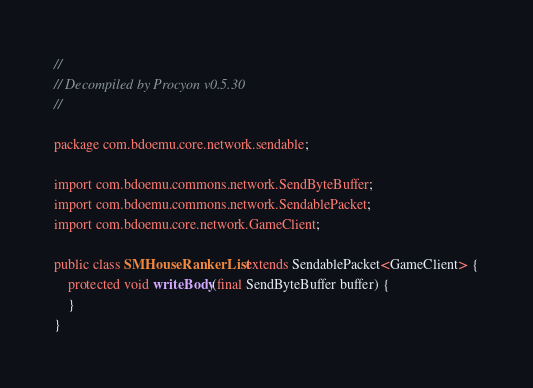<code> <loc_0><loc_0><loc_500><loc_500><_Java_>// 
// Decompiled by Procyon v0.5.30
// 

package com.bdoemu.core.network.sendable;

import com.bdoemu.commons.network.SendByteBuffer;
import com.bdoemu.commons.network.SendablePacket;
import com.bdoemu.core.network.GameClient;

public class SMHouseRankerList extends SendablePacket<GameClient> {
    protected void writeBody(final SendByteBuffer buffer) {
    }
}
</code> 